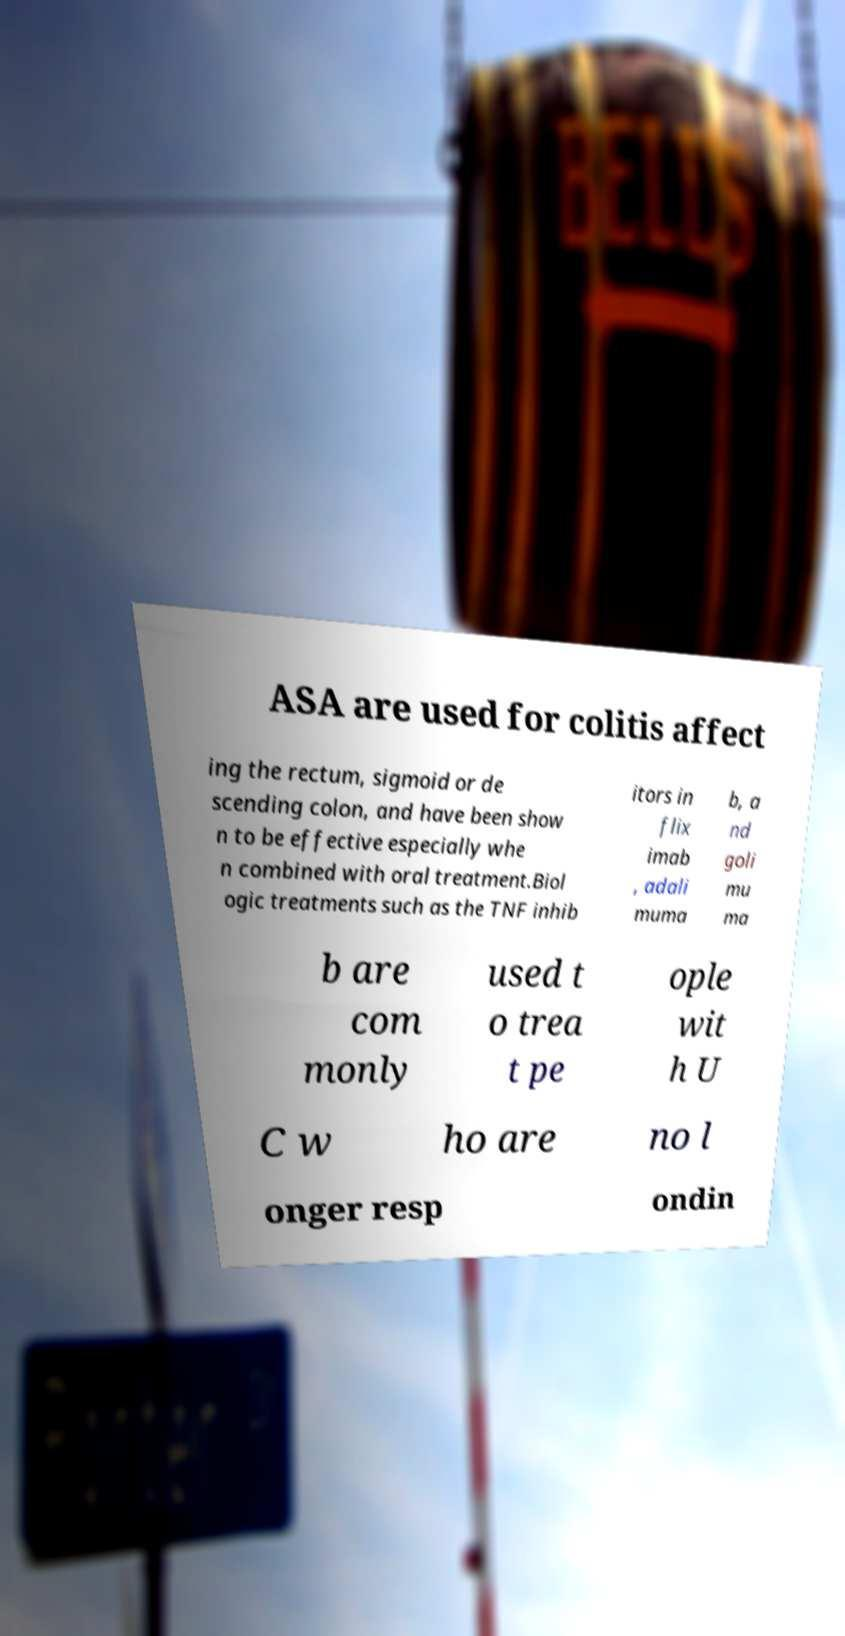What messages or text are displayed in this image? I need them in a readable, typed format. ASA are used for colitis affect ing the rectum, sigmoid or de scending colon, and have been show n to be effective especially whe n combined with oral treatment.Biol ogic treatments such as the TNF inhib itors in flix imab , adali muma b, a nd goli mu ma b are com monly used t o trea t pe ople wit h U C w ho are no l onger resp ondin 